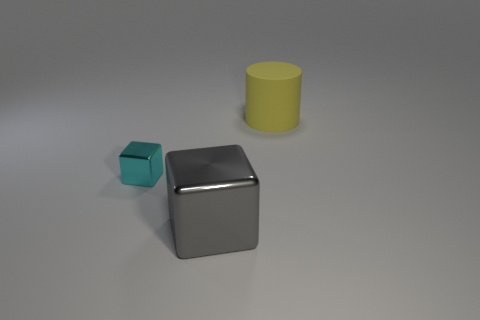Add 1 big yellow objects. How many objects exist? 4 Subtract all blocks. How many objects are left? 1 Add 2 large metal things. How many large metal things exist? 3 Subtract 0 purple cylinders. How many objects are left? 3 Subtract all cyan things. Subtract all big green metallic objects. How many objects are left? 2 Add 2 large rubber things. How many large rubber things are left? 3 